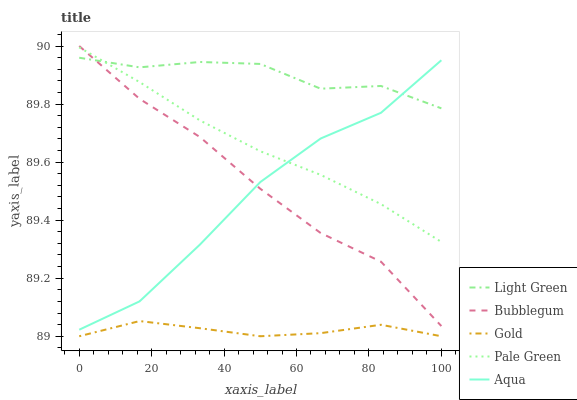Does Gold have the minimum area under the curve?
Answer yes or no. Yes. Does Light Green have the maximum area under the curve?
Answer yes or no. Yes. Does Pale Green have the minimum area under the curve?
Answer yes or no. No. Does Pale Green have the maximum area under the curve?
Answer yes or no. No. Is Pale Green the smoothest?
Answer yes or no. Yes. Is Aqua the roughest?
Answer yes or no. Yes. Is Aqua the smoothest?
Answer yes or no. No. Is Pale Green the roughest?
Answer yes or no. No. Does Pale Green have the lowest value?
Answer yes or no. No. Does Bubblegum have the highest value?
Answer yes or no. Yes. Does Pale Green have the highest value?
Answer yes or no. No. Is Gold less than Pale Green?
Answer yes or no. Yes. Is Aqua greater than Gold?
Answer yes or no. Yes. Does Pale Green intersect Bubblegum?
Answer yes or no. Yes. Is Pale Green less than Bubblegum?
Answer yes or no. No. Is Pale Green greater than Bubblegum?
Answer yes or no. No. Does Gold intersect Pale Green?
Answer yes or no. No. 